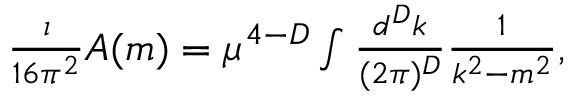<formula> <loc_0><loc_0><loc_500><loc_500>\begin{array} { r } { \frac { \imath } { 1 6 \pi ^ { 2 } } A ( m ) = \mu ^ { 4 - D } \int \frac { d ^ { D } k } { ( 2 \pi ) ^ { D } } \frac { 1 } { k ^ { 2 } - m ^ { 2 } } , } \end{array}</formula> 